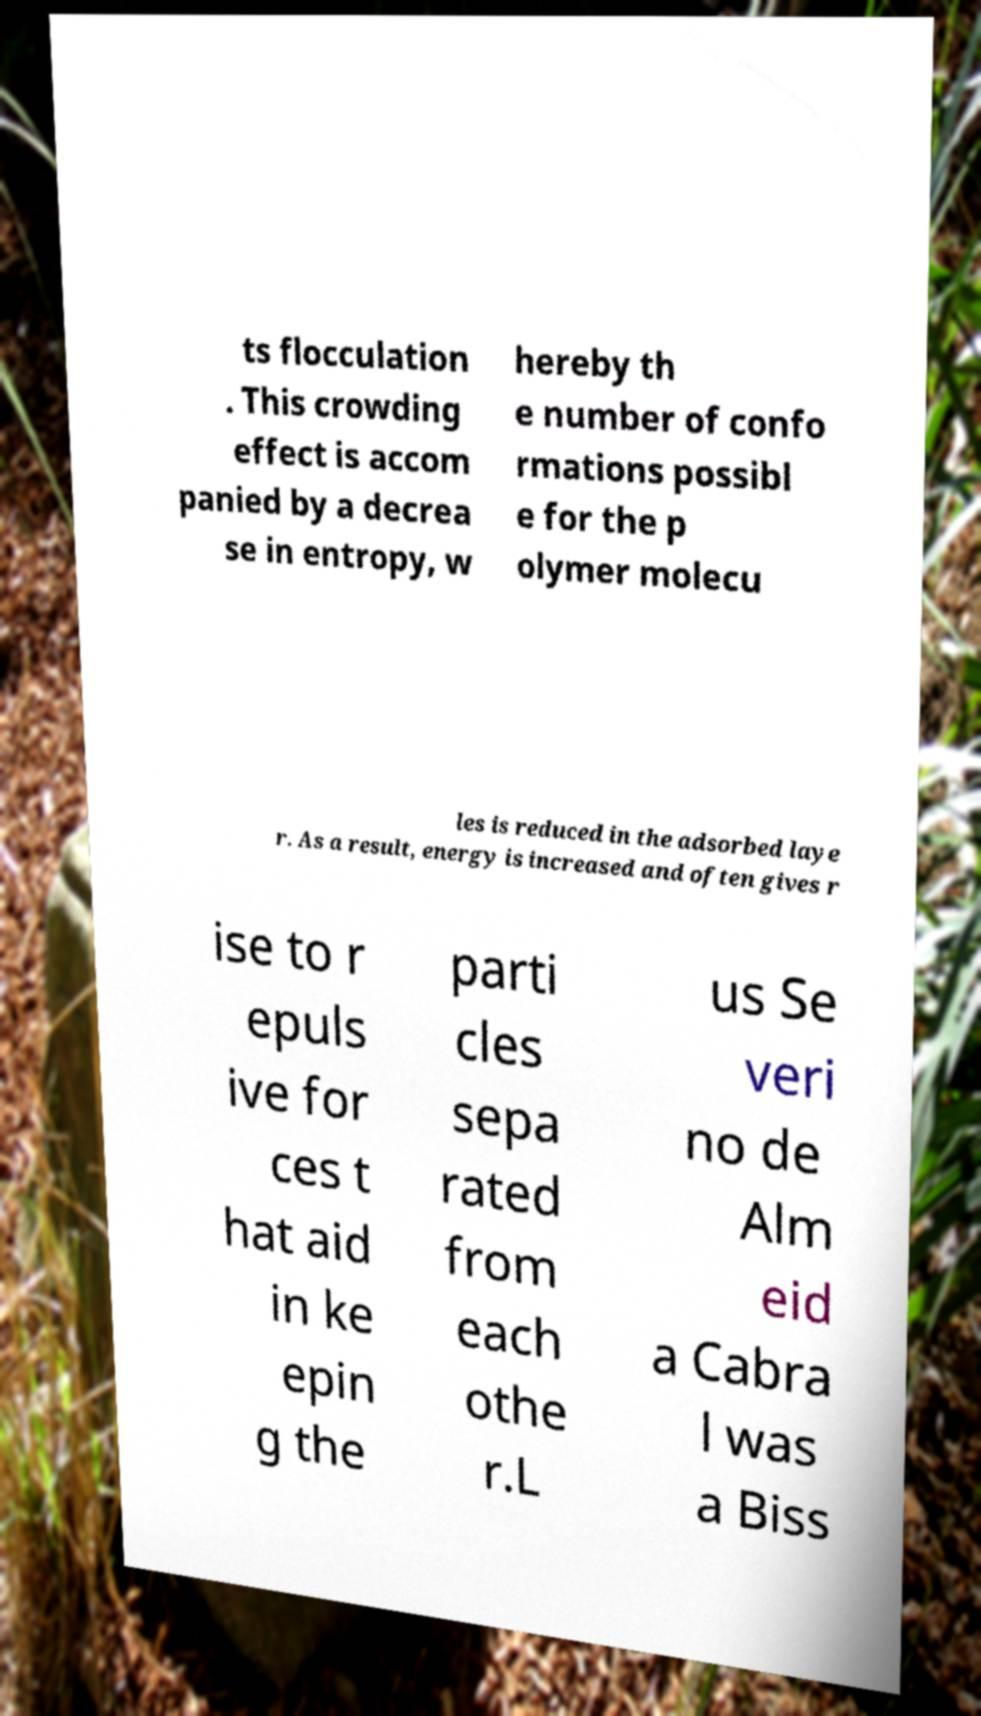Please read and relay the text visible in this image. What does it say? ts flocculation . This crowding effect is accom panied by a decrea se in entropy, w hereby th e number of confo rmations possibl e for the p olymer molecu les is reduced in the adsorbed laye r. As a result, energy is increased and often gives r ise to r epuls ive for ces t hat aid in ke epin g the parti cles sepa rated from each othe r.L us Se veri no de Alm eid a Cabra l was a Biss 